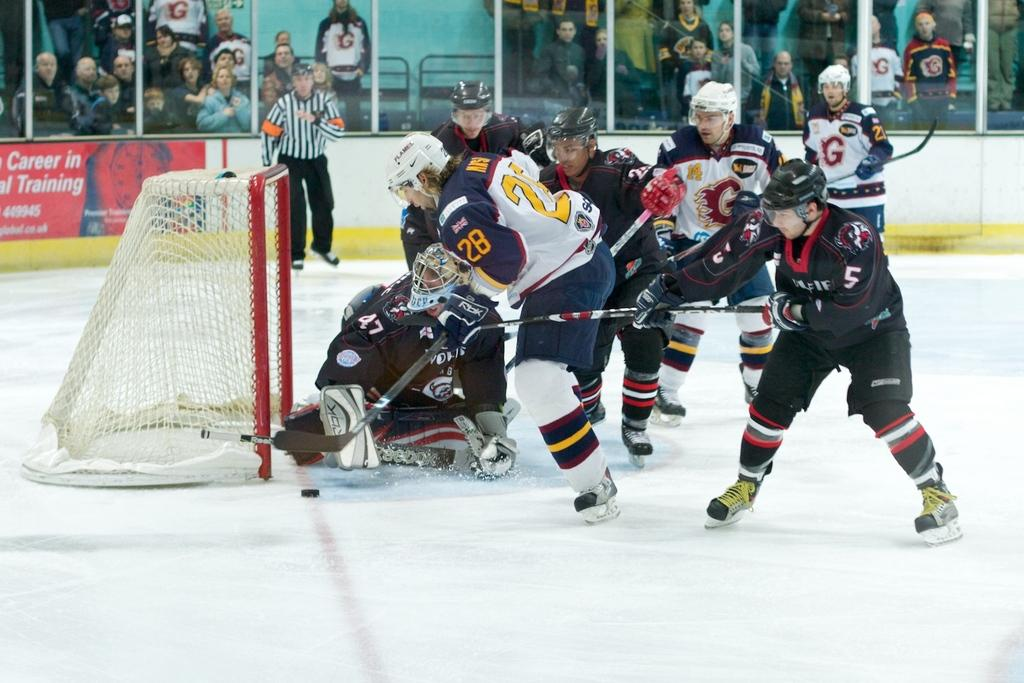<image>
Summarize the visual content of the image. Number 47 is trying hard not to let the puck get through. 